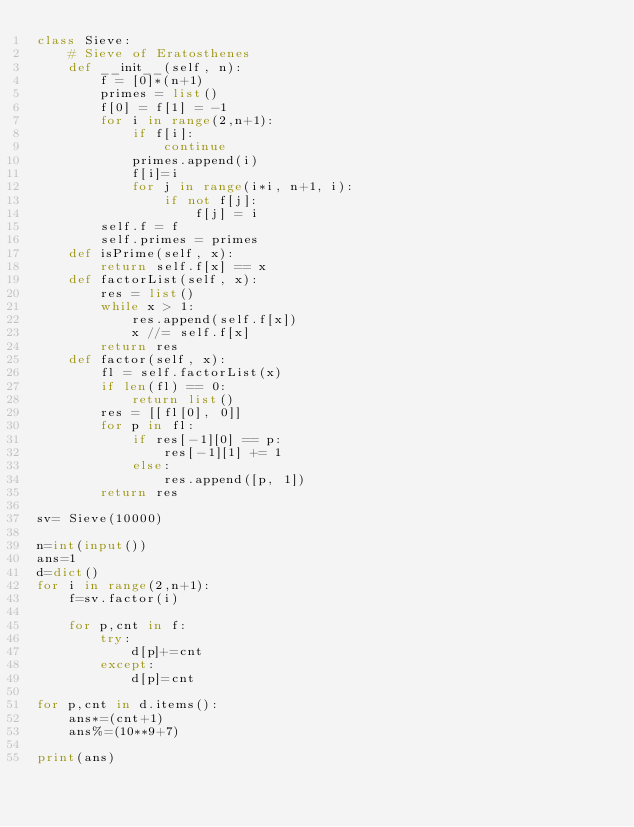<code> <loc_0><loc_0><loc_500><loc_500><_Python_>class Sieve:
    # Sieve of Eratosthenes
    def __init__(self, n):
        f = [0]*(n+1)
        primes = list()
        f[0] = f[1] = -1
        for i in range(2,n+1):
            if f[i]:
                continue
            primes.append(i)
            f[i]=i
            for j in range(i*i, n+1, i):
                if not f[j]:
                    f[j] = i
        self.f = f
        self.primes = primes
    def isPrime(self, x):
        return self.f[x] == x
    def factorList(self, x):
        res = list()
        while x > 1:
            res.append(self.f[x])
            x //= self.f[x]
        return res
    def factor(self, x):
        fl = self.factorList(x)
        if len(fl) == 0:
            return list()
        res = [[fl[0], 0]]
        for p in fl:
            if res[-1][0] == p:
                res[-1][1] += 1
            else:
                res.append([p, 1])
        return res

sv= Sieve(10000)

n=int(input())
ans=1
d=dict()
for i in range(2,n+1):
    f=sv.factor(i)

    for p,cnt in f:
        try:
            d[p]+=cnt
        except:
            d[p]=cnt

for p,cnt in d.items():
    ans*=(cnt+1)
    ans%=(10**9+7)

print(ans)


</code> 